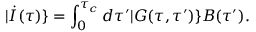<formula> <loc_0><loc_0><loc_500><loc_500>| \dot { I } ( \tau ) \} = \int _ { 0 } ^ { \tau _ { c } } d \tau ^ { \prime } | G ( \tau , \tau ^ { \prime } ) \} B ( \tau ^ { \prime } ) .</formula> 